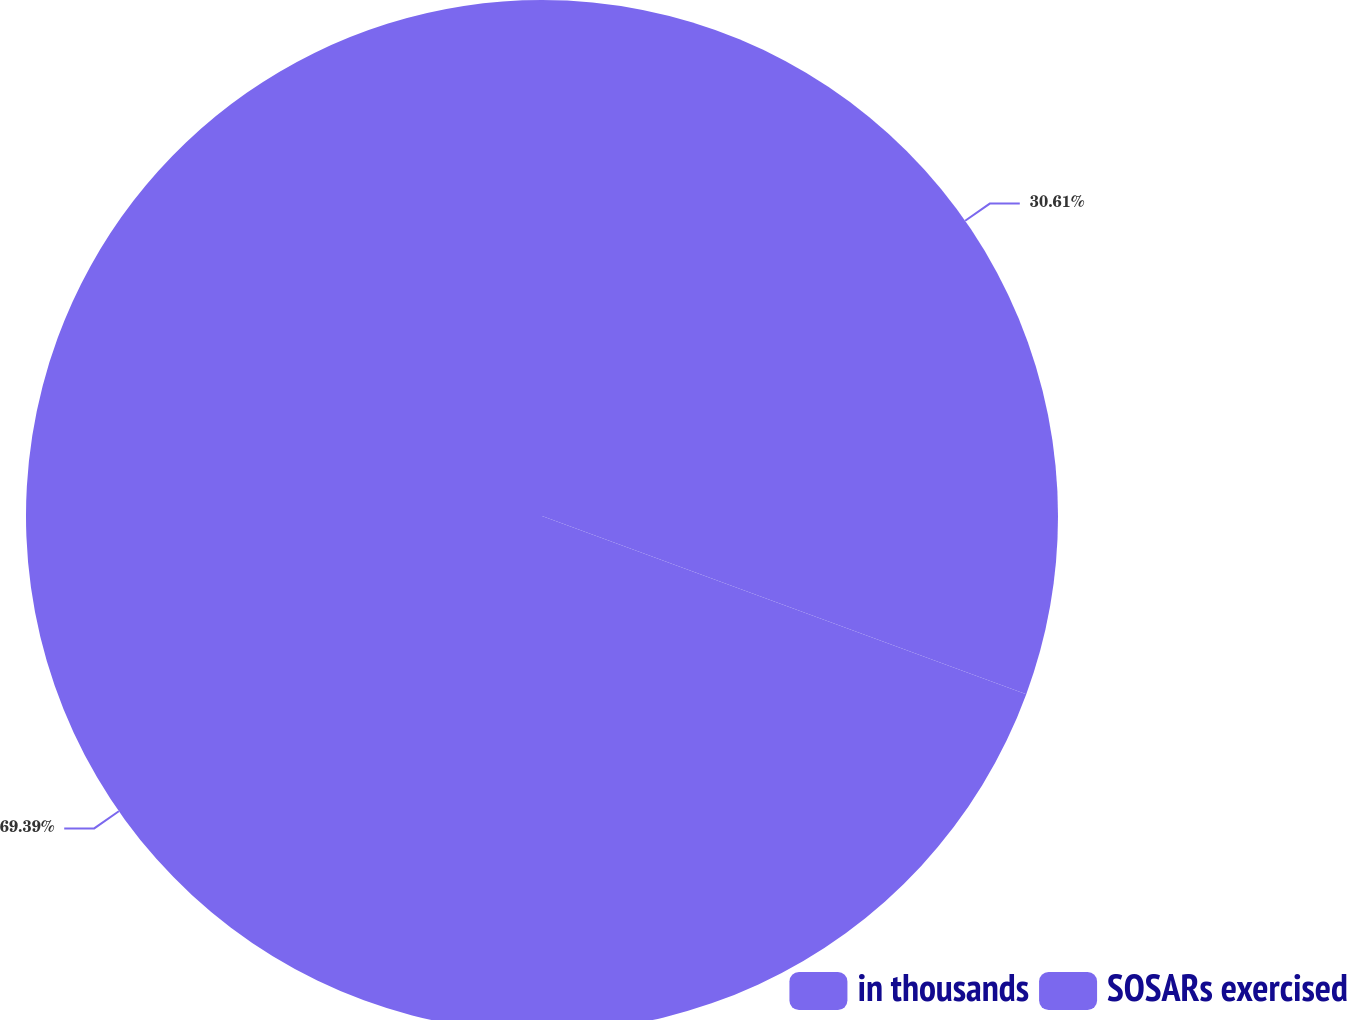Convert chart. <chart><loc_0><loc_0><loc_500><loc_500><pie_chart><fcel>in thousands<fcel>SOSARs exercised<nl><fcel>30.61%<fcel>69.39%<nl></chart> 